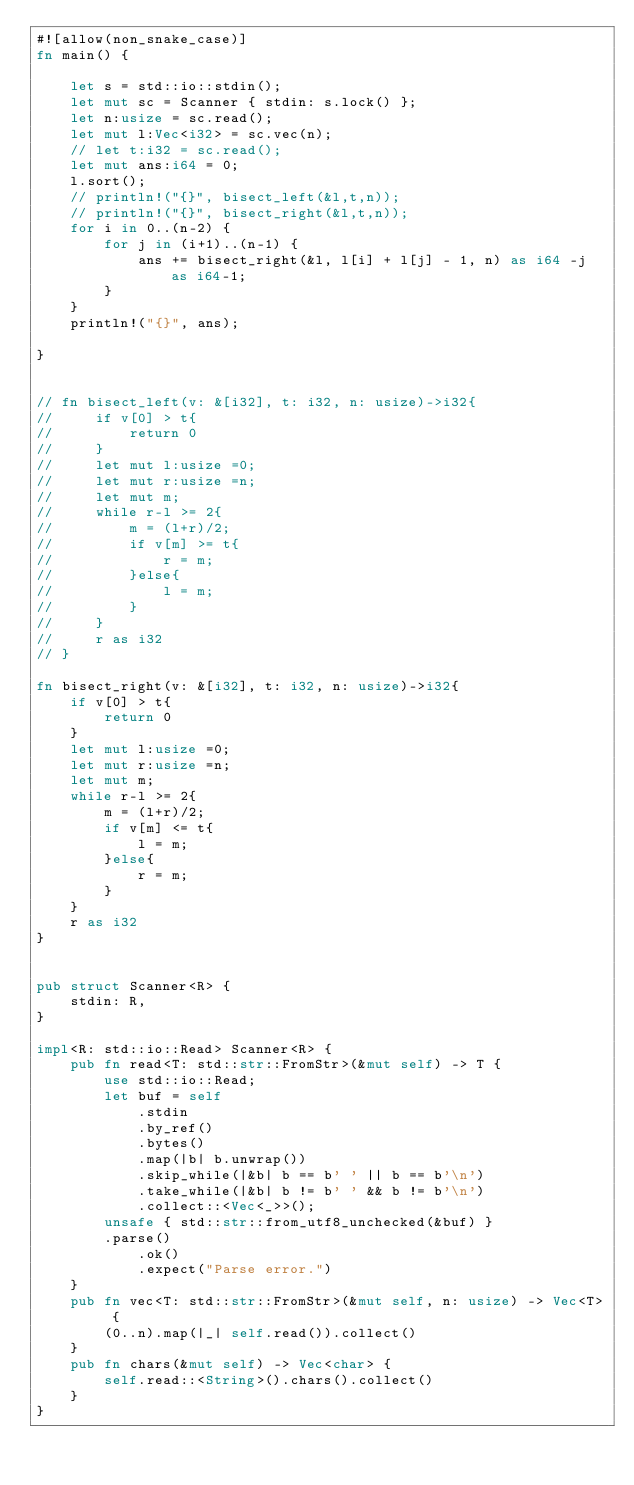Convert code to text. <code><loc_0><loc_0><loc_500><loc_500><_Rust_>#![allow(non_snake_case)]
fn main() {

    let s = std::io::stdin();
    let mut sc = Scanner { stdin: s.lock() };
    let n:usize = sc.read();
    let mut l:Vec<i32> = sc.vec(n);
    // let t:i32 = sc.read();
    let mut ans:i64 = 0;
    l.sort();
    // println!("{}", bisect_left(&l,t,n));
    // println!("{}", bisect_right(&l,t,n));
    for i in 0..(n-2) {
        for j in (i+1)..(n-1) {
            ans += bisect_right(&l, l[i] + l[j] - 1, n) as i64 -j as i64-1;
        }
    }
    println!("{}", ans);
    
}


// fn bisect_left(v: &[i32], t: i32, n: usize)->i32{
//     if v[0] > t{
//         return 0
//     }
//     let mut l:usize =0;
//     let mut r:usize =n;
//     let mut m;
//     while r-l >= 2{
//         m = (l+r)/2;
//         if v[m] >= t{
//             r = m;
//         }else{
//             l = m;
//         }
//     }
//     r as i32
// }

fn bisect_right(v: &[i32], t: i32, n: usize)->i32{
    if v[0] > t{
        return 0
    }
    let mut l:usize =0;
    let mut r:usize =n;
    let mut m;
    while r-l >= 2{
        m = (l+r)/2;
        if v[m] <= t{
            l = m;
        }else{
            r = m;
        }
    }
    r as i32
}


pub struct Scanner<R> {
    stdin: R,
}

impl<R: std::io::Read> Scanner<R> {
    pub fn read<T: std::str::FromStr>(&mut self) -> T {
        use std::io::Read;
        let buf = self
            .stdin
            .by_ref()
            .bytes()
            .map(|b| b.unwrap())
            .skip_while(|&b| b == b' ' || b == b'\n')
            .take_while(|&b| b != b' ' && b != b'\n')
            .collect::<Vec<_>>();
        unsafe { std::str::from_utf8_unchecked(&buf) }
        .parse()
            .ok()
            .expect("Parse error.")
    }
    pub fn vec<T: std::str::FromStr>(&mut self, n: usize) -> Vec<T> {
        (0..n).map(|_| self.read()).collect()
    }
    pub fn chars(&mut self) -> Vec<char> {
        self.read::<String>().chars().collect()
    }
}

</code> 